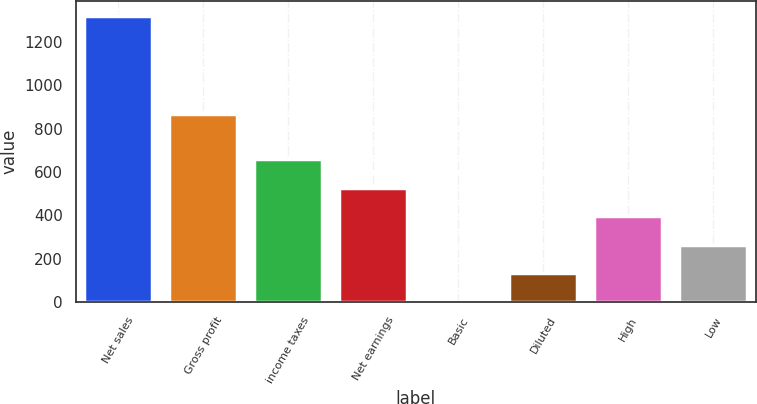Convert chart to OTSL. <chart><loc_0><loc_0><loc_500><loc_500><bar_chart><fcel>Net sales<fcel>Gross profit<fcel>income taxes<fcel>Net earnings<fcel>Basic<fcel>Diluted<fcel>High<fcel>Low<nl><fcel>1320.9<fcel>868<fcel>660.61<fcel>528.56<fcel>0.36<fcel>132.41<fcel>396.51<fcel>264.46<nl></chart> 